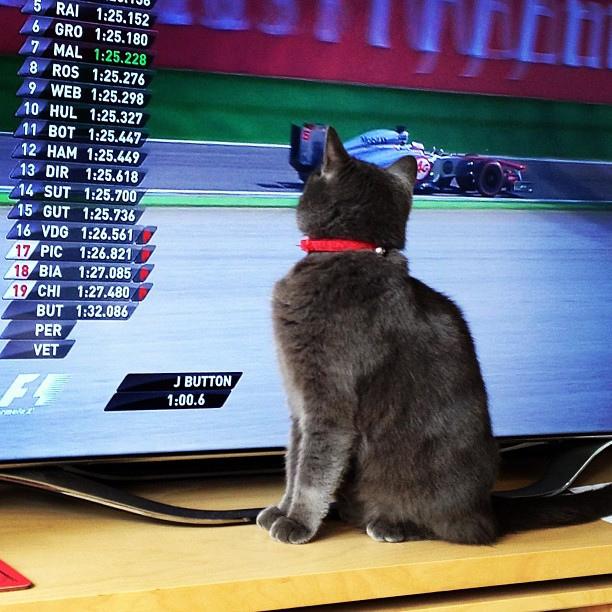What sport is this cat watching on the television?
Short answer required. Racing. What initials are shown as being in tenth place?
Quick response, please. Hull. What is the cat's collar's color?
Concise answer only. Red. 